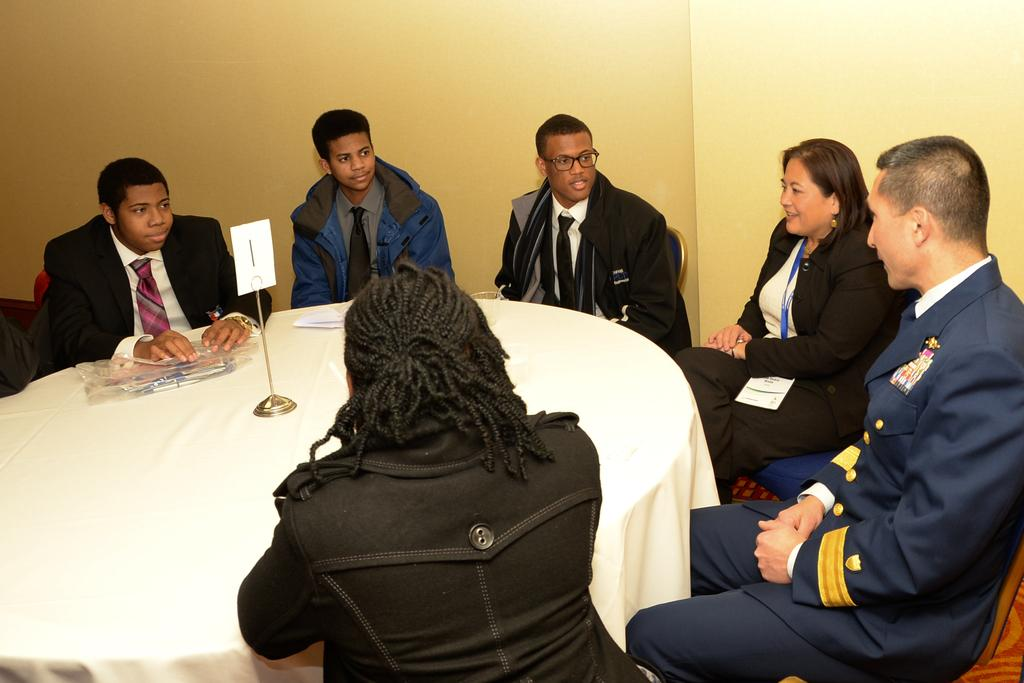What are the people in the image doing? The people in the image are sitting in chairs. What is located in front of the chairs? There is a table in front of the chairs. What can be seen on the table? There are objects on the table. What is visible behind the people and the table? There is a wall behind the people and the table. How many toes are visible on the people in the image? There is no way to determine the number of toes visible on the people in the image, as their feet are not shown. 